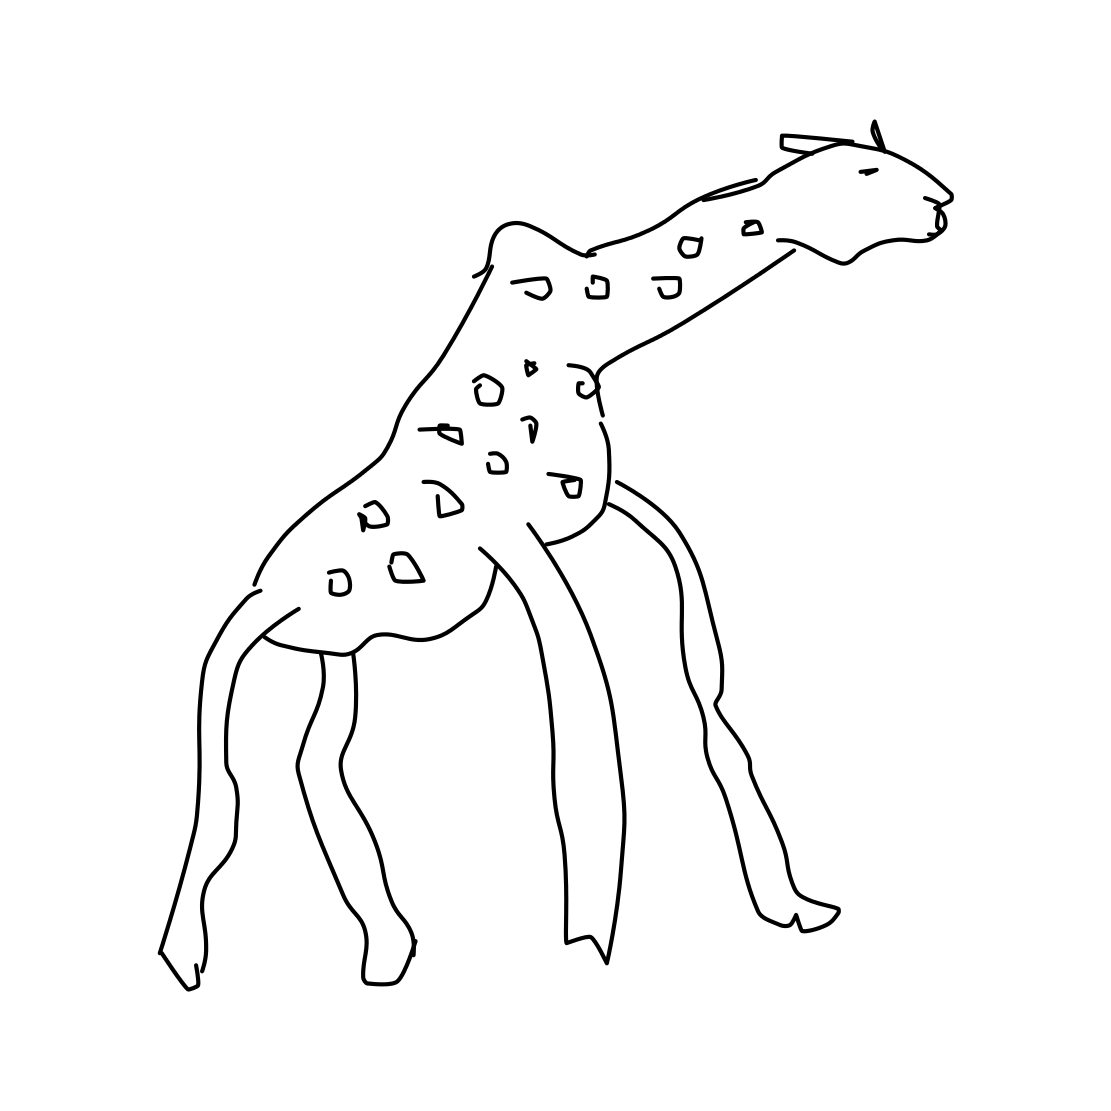In the scene, is a comb in it? No 